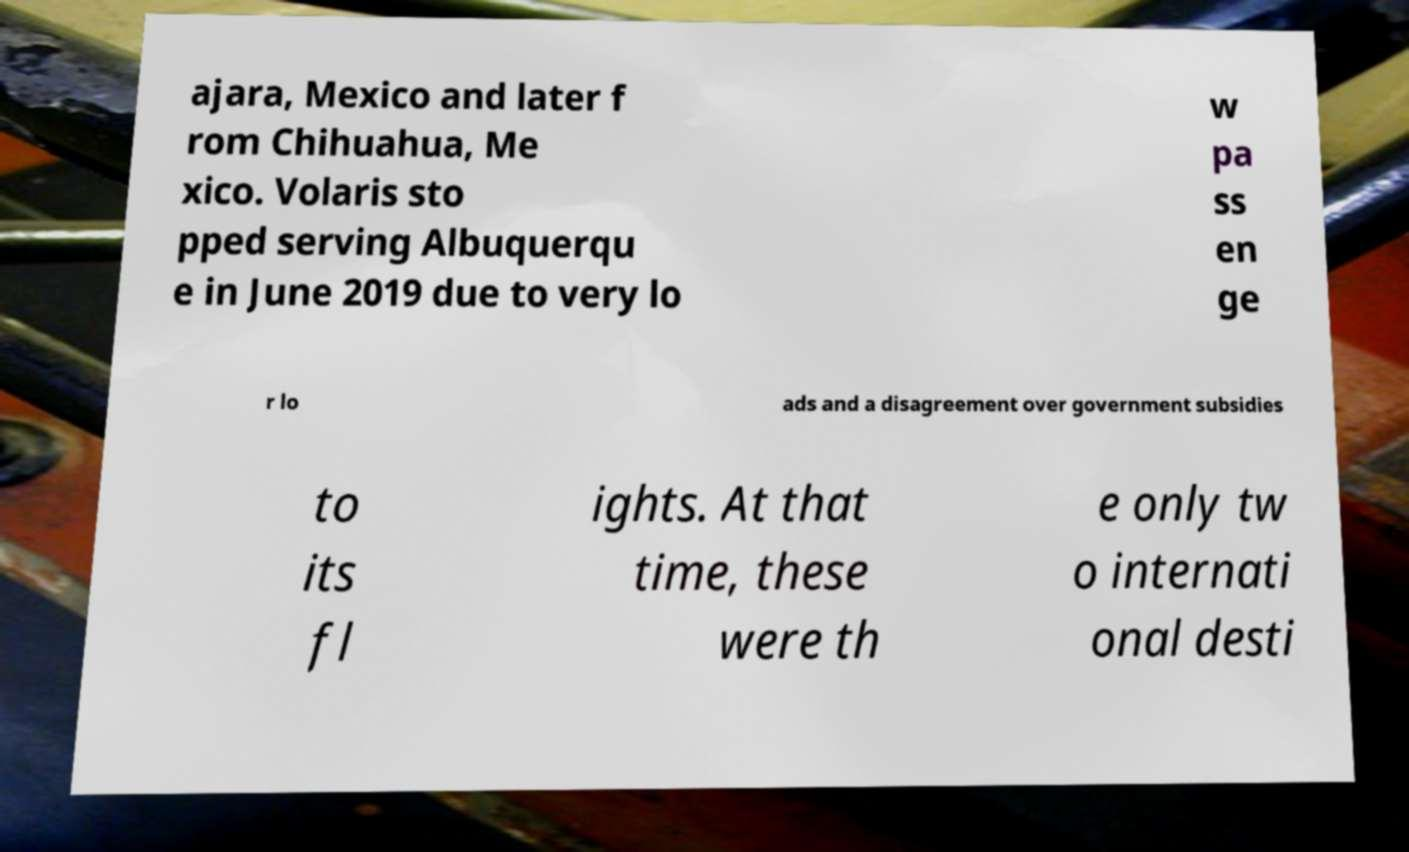Can you read and provide the text displayed in the image?This photo seems to have some interesting text. Can you extract and type it out for me? ajara, Mexico and later f rom Chihuahua, Me xico. Volaris sto pped serving Albuquerqu e in June 2019 due to very lo w pa ss en ge r lo ads and a disagreement over government subsidies to its fl ights. At that time, these were th e only tw o internati onal desti 